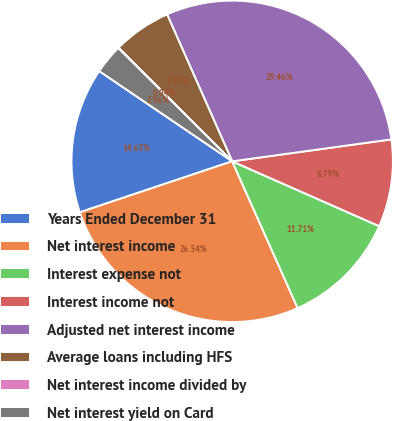Convert chart to OTSL. <chart><loc_0><loc_0><loc_500><loc_500><pie_chart><fcel>Years Ended December 31<fcel>Net interest income<fcel>Interest expense not<fcel>Interest income not<fcel>Adjusted net interest income<fcel>Average loans including HFS<fcel>Net interest income divided by<fcel>Net interest yield on Card<nl><fcel>14.63%<fcel>26.54%<fcel>11.71%<fcel>8.79%<fcel>29.46%<fcel>5.87%<fcel>0.04%<fcel>2.96%<nl></chart> 